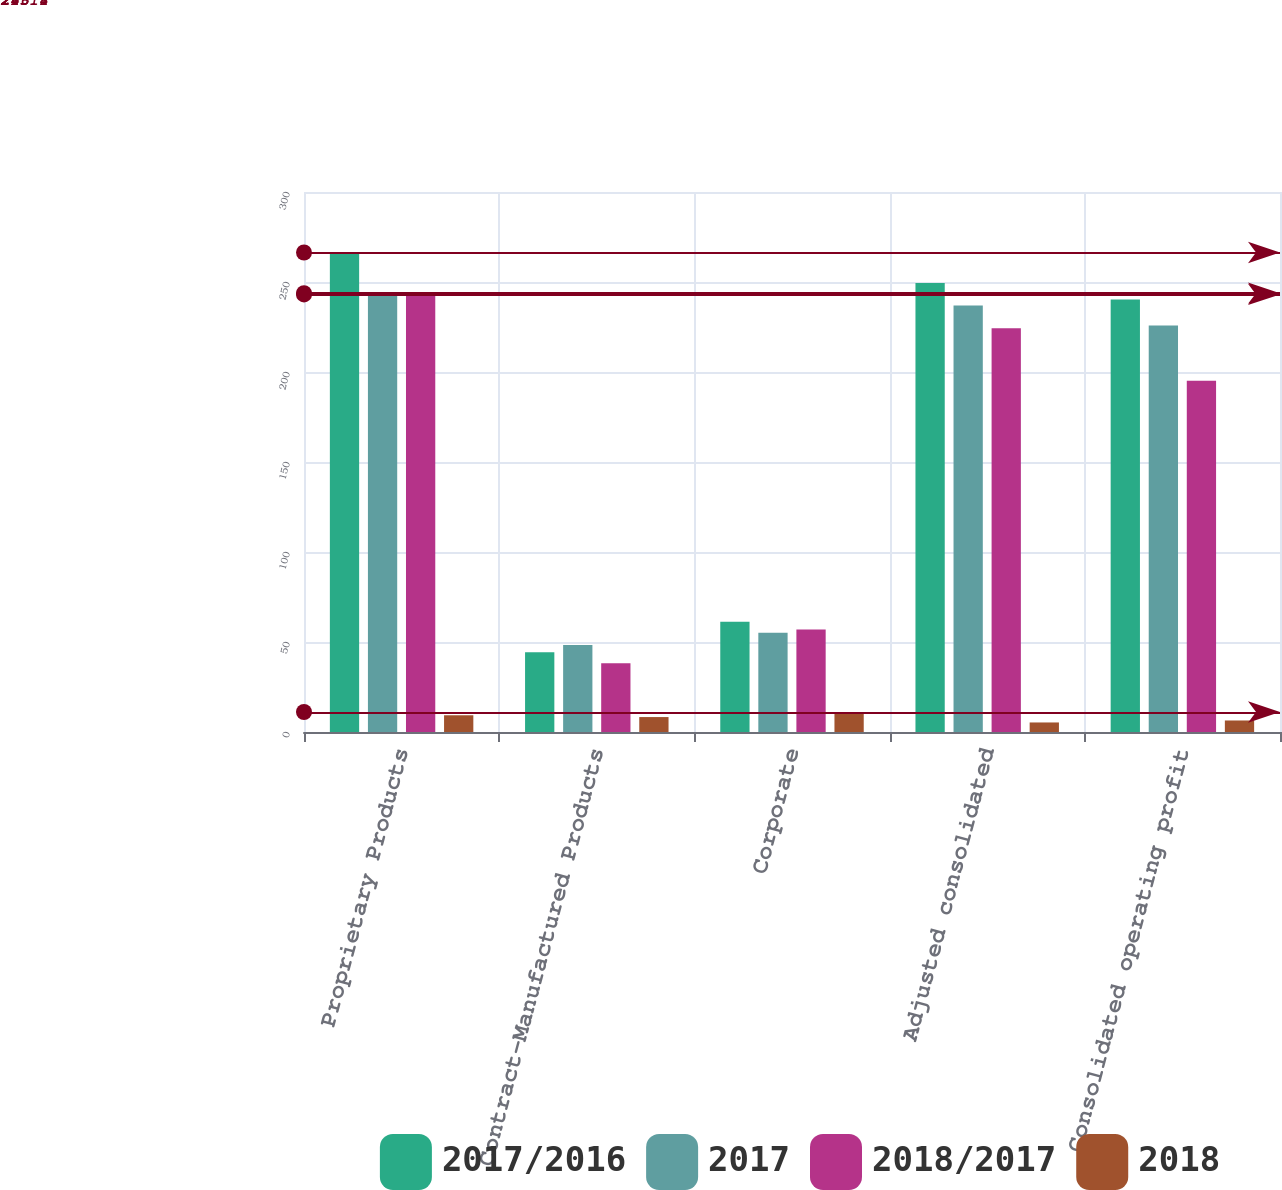Convert chart. <chart><loc_0><loc_0><loc_500><loc_500><stacked_bar_chart><ecel><fcel>Proprietary Products<fcel>Contract-Manufactured Products<fcel>Corporate<fcel>Adjusted consolidated<fcel>Consolidated operating profit<nl><fcel>2017/2016<fcel>266.4<fcel>44.3<fcel>61.3<fcel>249.4<fcel>240.3<nl><fcel>2017<fcel>243.8<fcel>48.3<fcel>55.2<fcel>236.9<fcel>225.8<nl><fcel>2018/2017<fcel>243.1<fcel>38.2<fcel>57<fcel>224.3<fcel>195.2<nl><fcel>2018<fcel>9.3<fcel>8.3<fcel>11.1<fcel>5.3<fcel>6.4<nl></chart> 